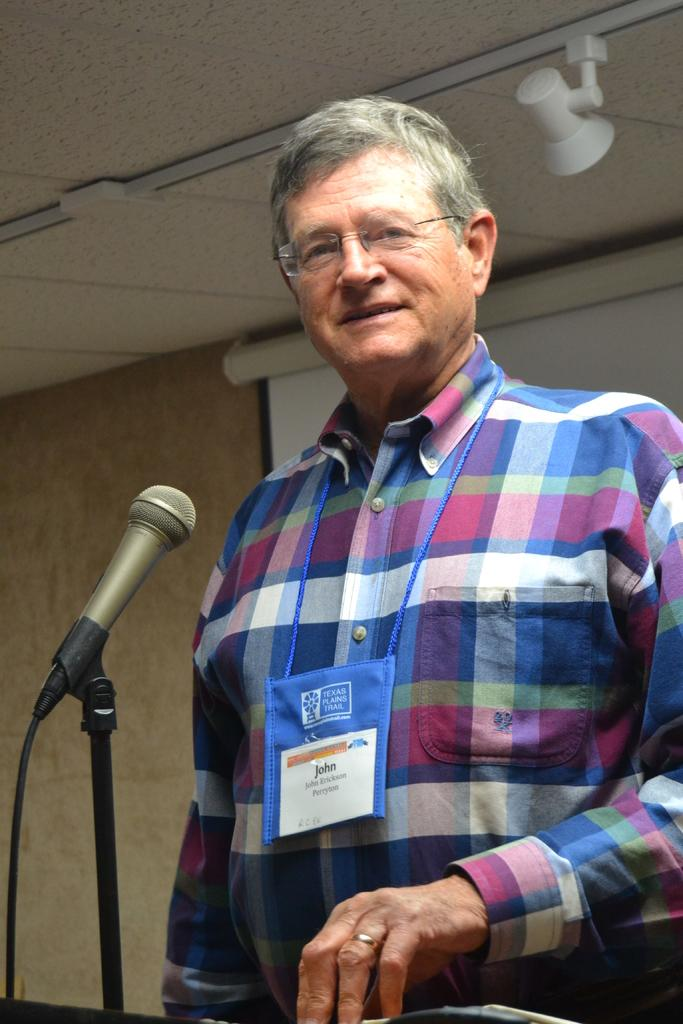What is the person in the image doing? The person is standing at a mic in the image. What can be seen behind the person? There is a screen and light visible in the background of the image. What type of structure is present in the background? There is a wall in the background of the image. What type of pet is sitting on the person's shoulder in the image? There is no pet visible in the image; the person is standing at a mic without any animals present. 